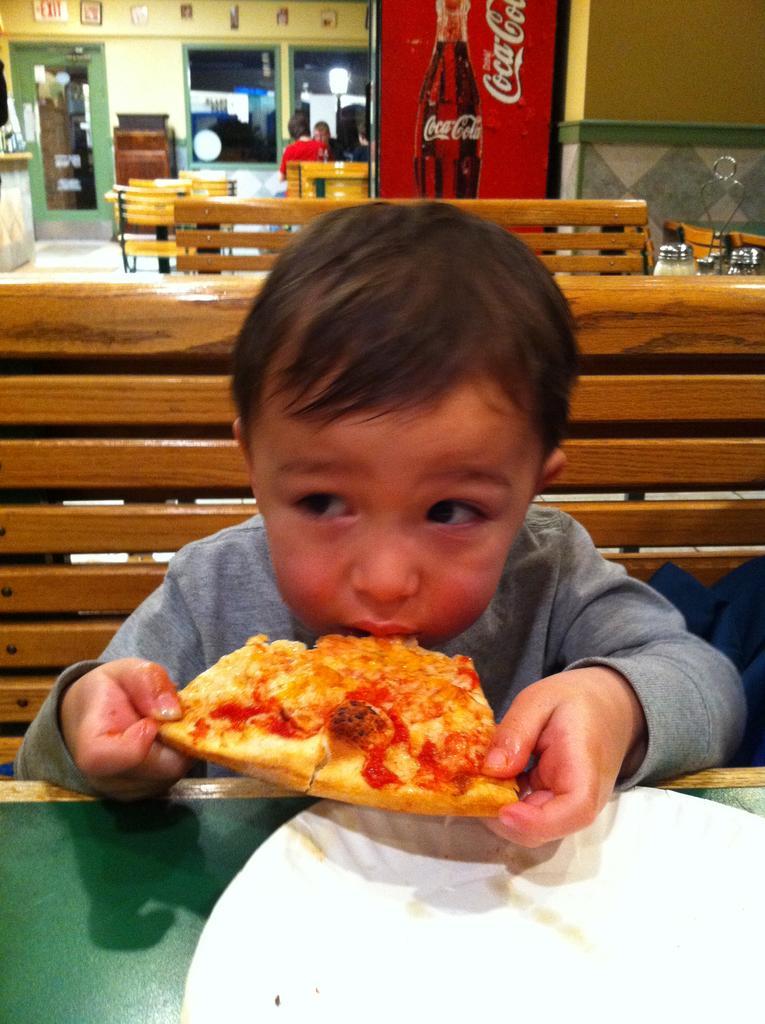Please provide a concise description of this image. In this picture there is a kid sitting on a bench and holding a slice of pizza in his hands and eating it and there is a plate in front of him and there are few benches,chairs,refrigerator and some other objects in the background. 